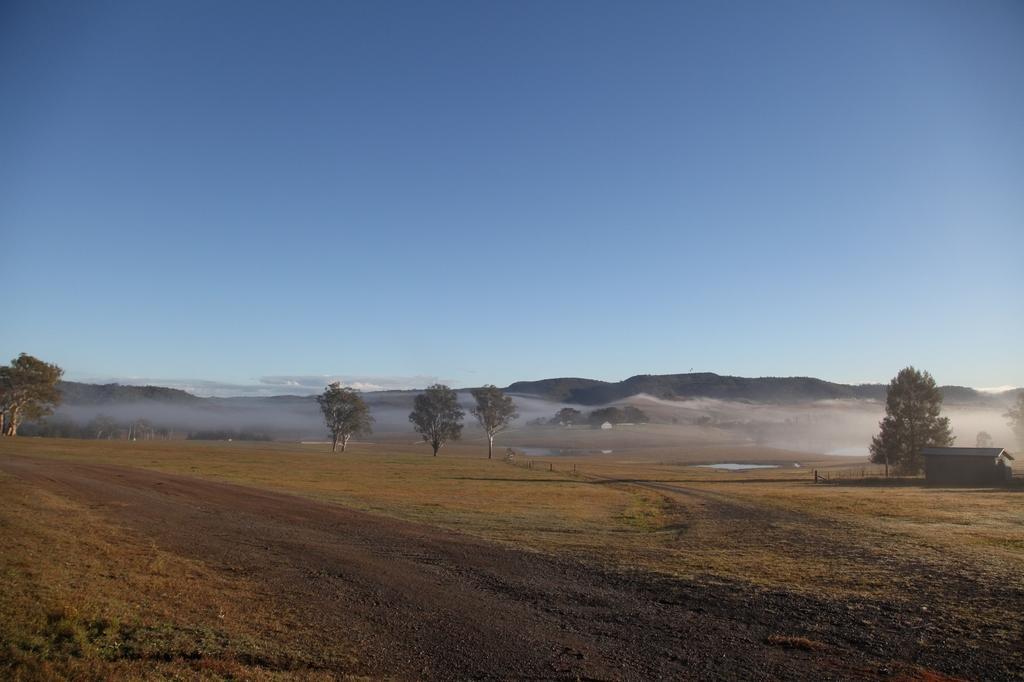Please provide a concise description of this image. In the image most of the land is empty and there are few trees and on the right side there is a hut and there are two small ponds in between the land and in the background there are mountains. 